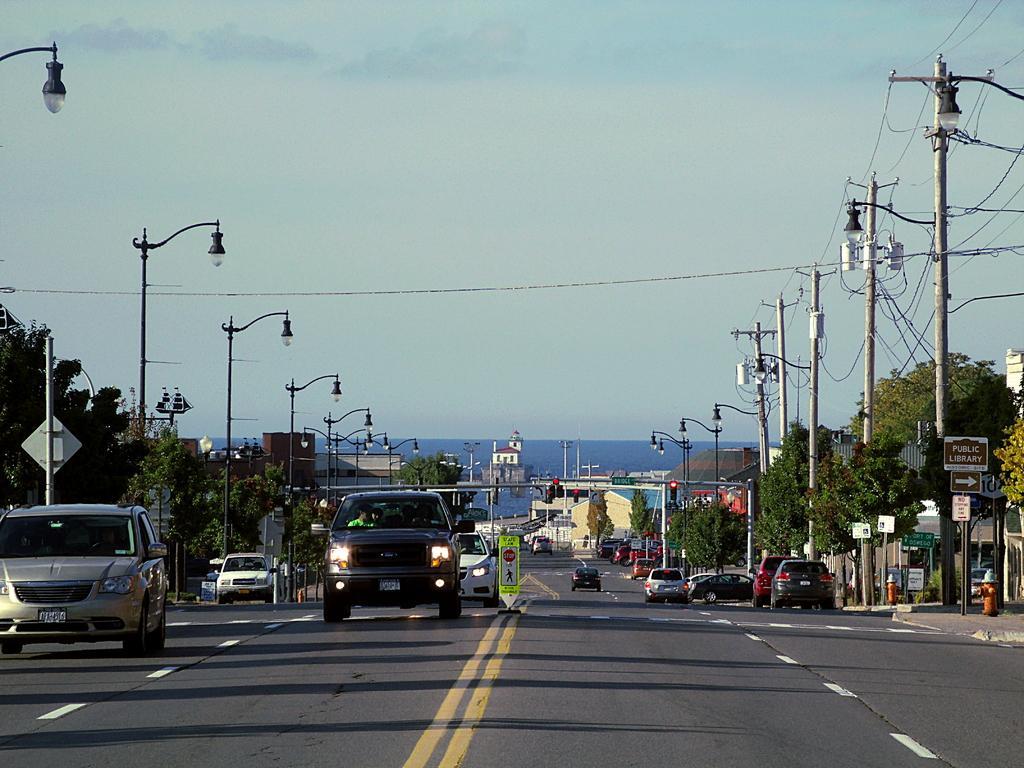How would you summarize this image in a sentence or two? In this image few vehicles are on the road. Few street lights are on both sides of the road. Right side there are few poles connected with wires. Right side few fire hydrants are on the pavement. Few boards are attached to the pole. Background there are trees and buildings. Top of the image the image there is sky. Middle of the road there is a board. 